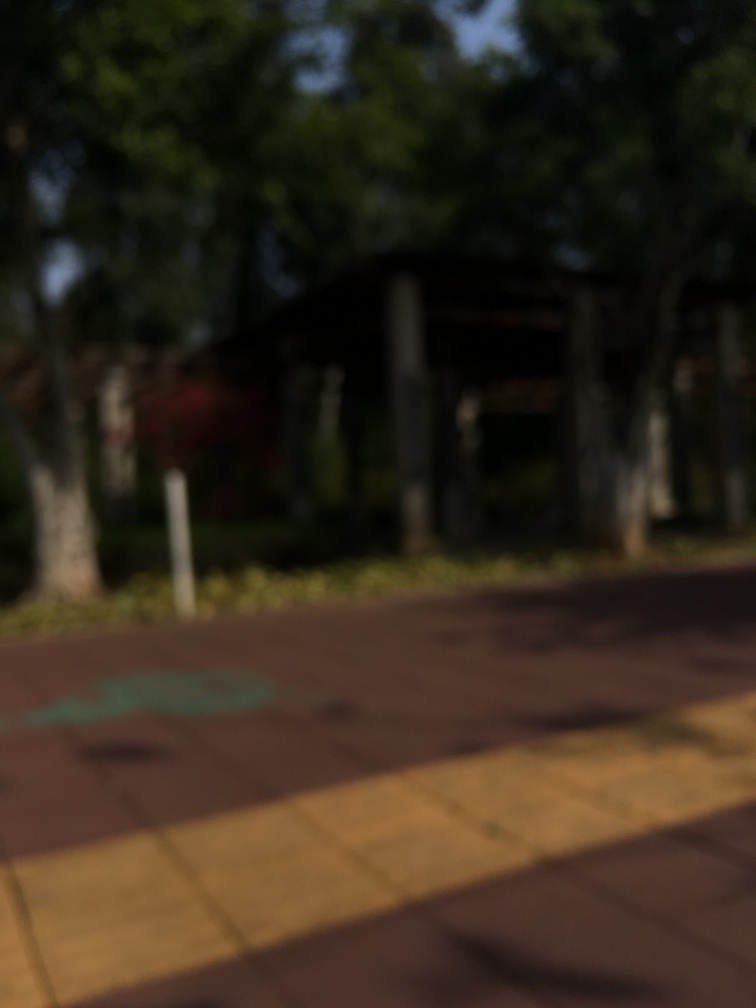Is the image clear and well focused?
A. Yes
B. No
Answer with the option's letter from the given choices directly.
 B. 